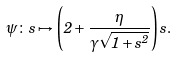Convert formula to latex. <formula><loc_0><loc_0><loc_500><loc_500>\psi \colon s \mapsto \left ( 2 + \frac { \eta } { \gamma \sqrt { 1 + s ^ { 2 } } } \right ) s .</formula> 